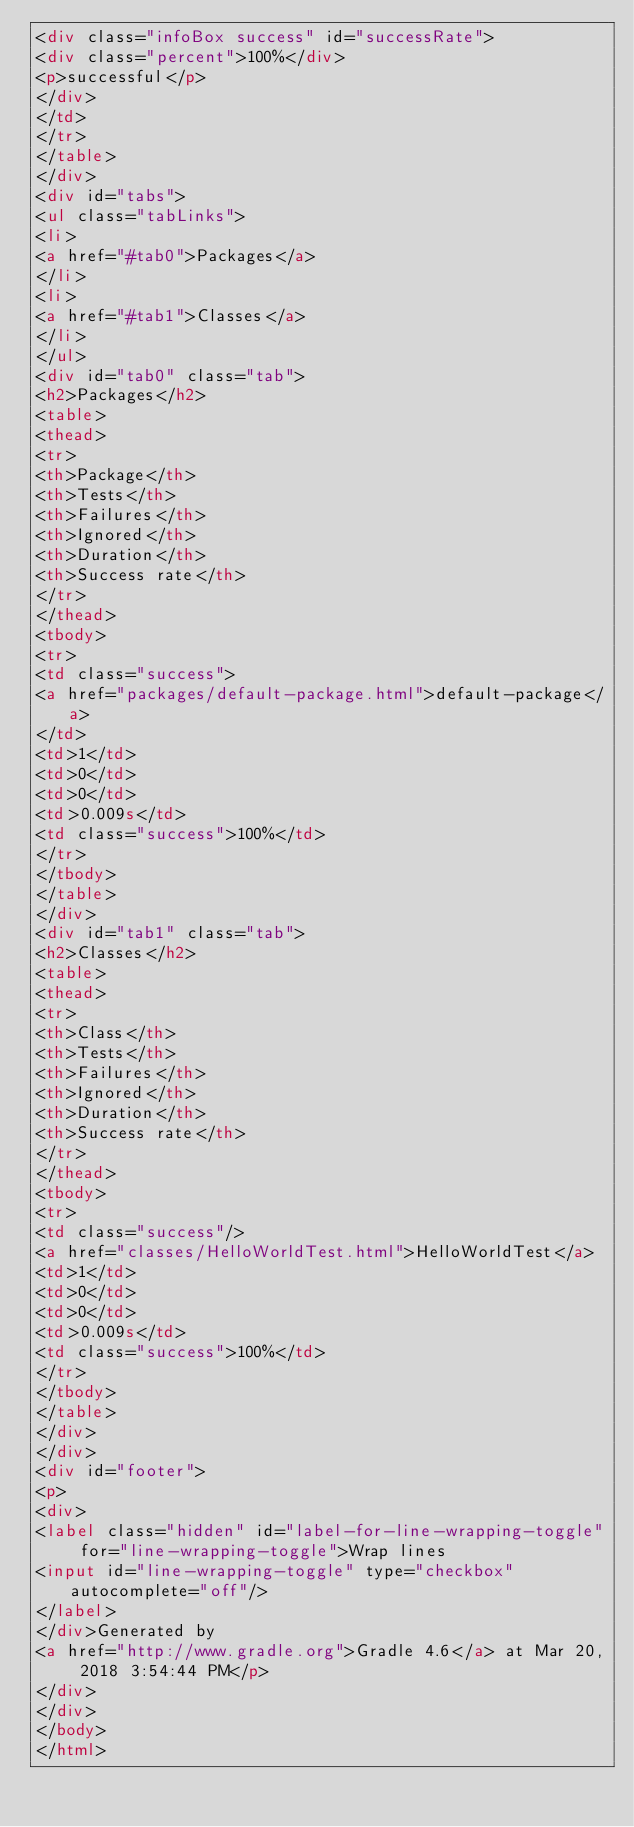Convert code to text. <code><loc_0><loc_0><loc_500><loc_500><_HTML_><div class="infoBox success" id="successRate">
<div class="percent">100%</div>
<p>successful</p>
</div>
</td>
</tr>
</table>
</div>
<div id="tabs">
<ul class="tabLinks">
<li>
<a href="#tab0">Packages</a>
</li>
<li>
<a href="#tab1">Classes</a>
</li>
</ul>
<div id="tab0" class="tab">
<h2>Packages</h2>
<table>
<thead>
<tr>
<th>Package</th>
<th>Tests</th>
<th>Failures</th>
<th>Ignored</th>
<th>Duration</th>
<th>Success rate</th>
</tr>
</thead>
<tbody>
<tr>
<td class="success">
<a href="packages/default-package.html">default-package</a>
</td>
<td>1</td>
<td>0</td>
<td>0</td>
<td>0.009s</td>
<td class="success">100%</td>
</tr>
</tbody>
</table>
</div>
<div id="tab1" class="tab">
<h2>Classes</h2>
<table>
<thead>
<tr>
<th>Class</th>
<th>Tests</th>
<th>Failures</th>
<th>Ignored</th>
<th>Duration</th>
<th>Success rate</th>
</tr>
</thead>
<tbody>
<tr>
<td class="success"/>
<a href="classes/HelloWorldTest.html">HelloWorldTest</a>
<td>1</td>
<td>0</td>
<td>0</td>
<td>0.009s</td>
<td class="success">100%</td>
</tr>
</tbody>
</table>
</div>
</div>
<div id="footer">
<p>
<div>
<label class="hidden" id="label-for-line-wrapping-toggle" for="line-wrapping-toggle">Wrap lines
<input id="line-wrapping-toggle" type="checkbox" autocomplete="off"/>
</label>
</div>Generated by 
<a href="http://www.gradle.org">Gradle 4.6</a> at Mar 20, 2018 3:54:44 PM</p>
</div>
</div>
</body>
</html>
</code> 